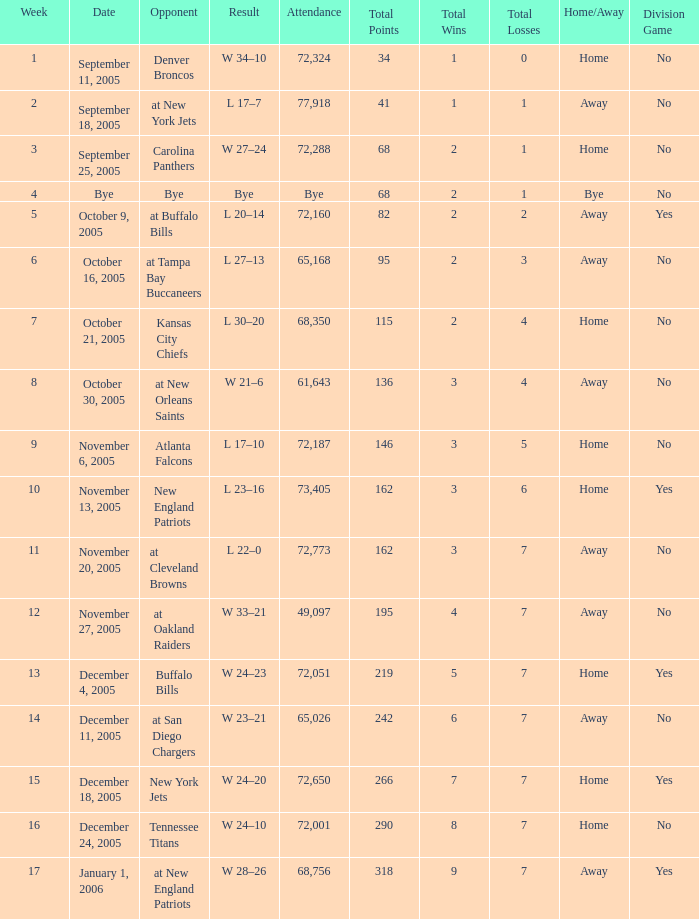Who was the Opponent on November 27, 2005? At oakland raiders. 